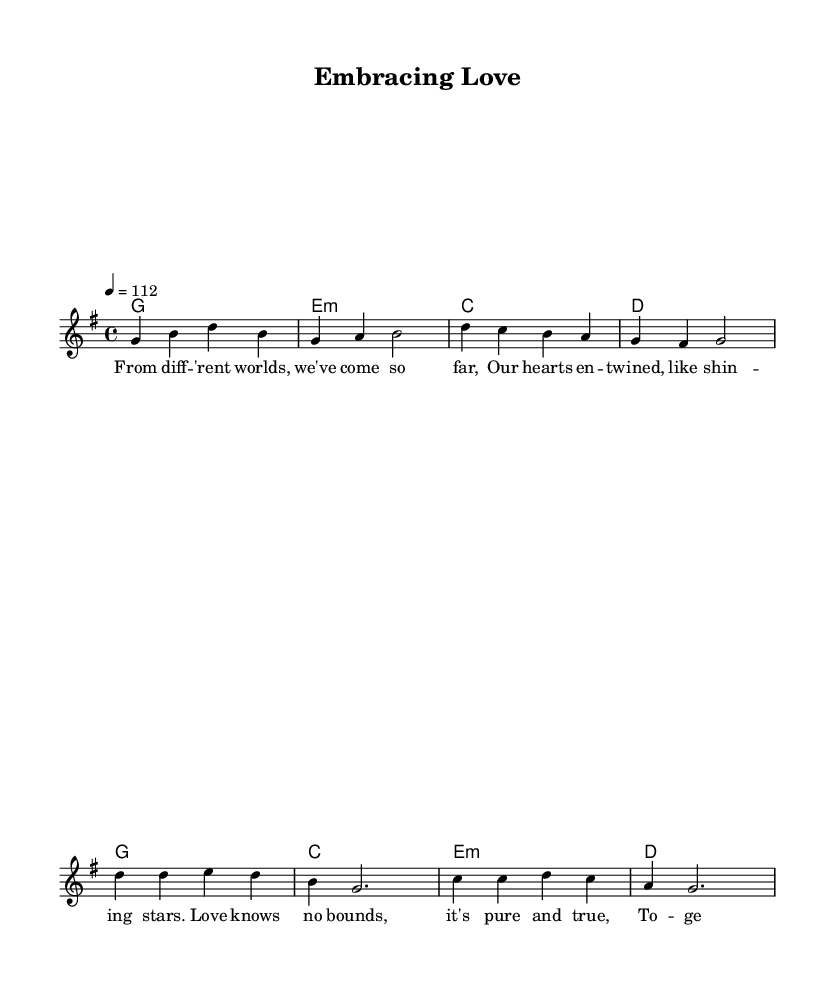What is the key signature of this music? The key signature is G major, which has one sharp (F#). You can find the key signature at the beginning of the sheet music, where it indicates the major key being used.
Answer: G major What is the time signature of this piece? The time signature is 4/4. It is found at the beginning of the score, indicating that there are four beats in a measure and the quarter note receives one beat.
Answer: 4/4 What is the tempo of the music? The tempo is 112 beats per minute. This is indicated at the beginning of the score with the markings that show how quickly the piece should be played.
Answer: 112 How many measures are there in the verse section? There are four measures in the verse section. By counting the bars in the melody line designated as the verse, you find that it consists of four groupings of notes.
Answer: 4 What chords are used in the chorus? The chords used in the chorus are G, C, E minor, and D. You can determine this by looking at the harmonies listed in the chord mode section that correspond to the melody of the chorus.
Answer: G, C, E minor, D What is the theme expressed in the lyrics? The theme expressed in the lyrics is family love and togetherness. By reading the lyrics, it is clear they convey messages of unity and support regardless of background, typical of uplifting world music.
Answer: Family love and togetherness 